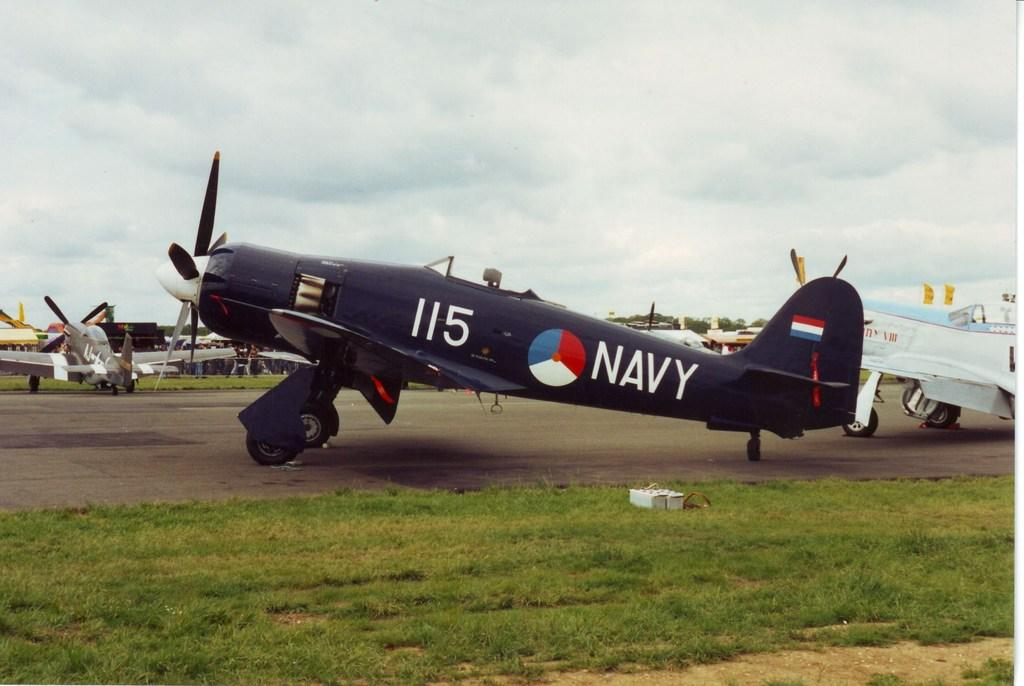What type of vehicles are on the ground in the image? There are aircrafts on the ground in the image. What type of natural elements can be seen in the image? There are trees and grass in the image. What type of man-made structures are present in the image? There are buildings in the image. What is visible in the background of the image? The sky is visible in the background of the image. Can you tell me which direction the bear is facing in the image? There is no bear present in the image. 